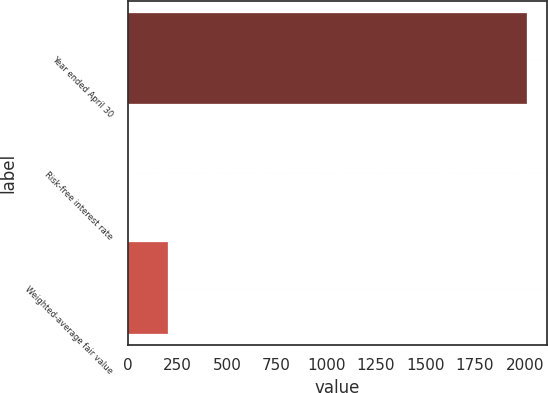<chart> <loc_0><loc_0><loc_500><loc_500><bar_chart><fcel>Year ended April 30<fcel>Risk-free interest rate<fcel>Weighted-average fair value<nl><fcel>2013<fcel>0.4<fcel>201.66<nl></chart> 